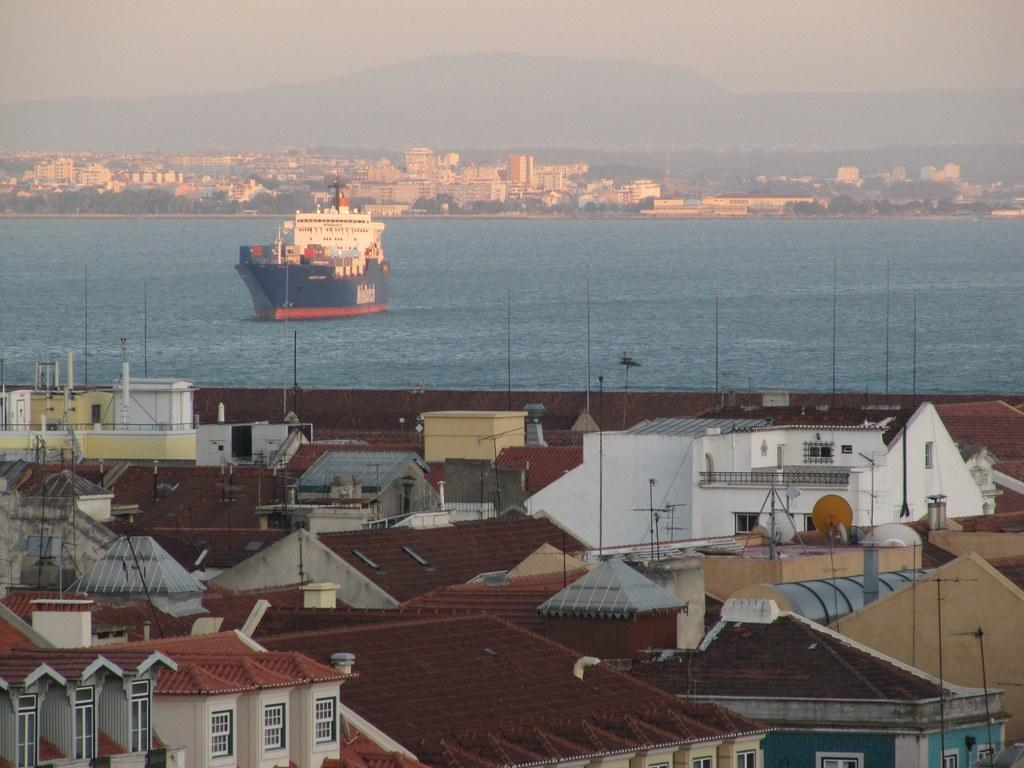What type of structures can be seen in the image? There are houses in the image. What can be seen in the background of the image? There is a boat, water, buildings, mountains, trees, and the sky visible in the background of the image. How many different types of natural elements are present in the background of the image? There are four different types of natural elements present in the background of the image: water, mountains, trees, and the sky. Where is the tray located in the image? There is no tray present in the image. What type of flame can be seen coming from the son's hand in the image? There is no son or flame present in the image. 